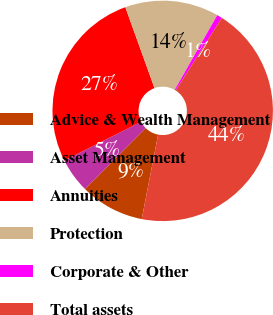Convert chart to OTSL. <chart><loc_0><loc_0><loc_500><loc_500><pie_chart><fcel>Advice & Wealth Management<fcel>Asset Management<fcel>Annuities<fcel>Protection<fcel>Corporate & Other<fcel>Total assets<nl><fcel>9.42%<fcel>5.09%<fcel>26.93%<fcel>13.75%<fcel>0.76%<fcel>44.04%<nl></chart> 